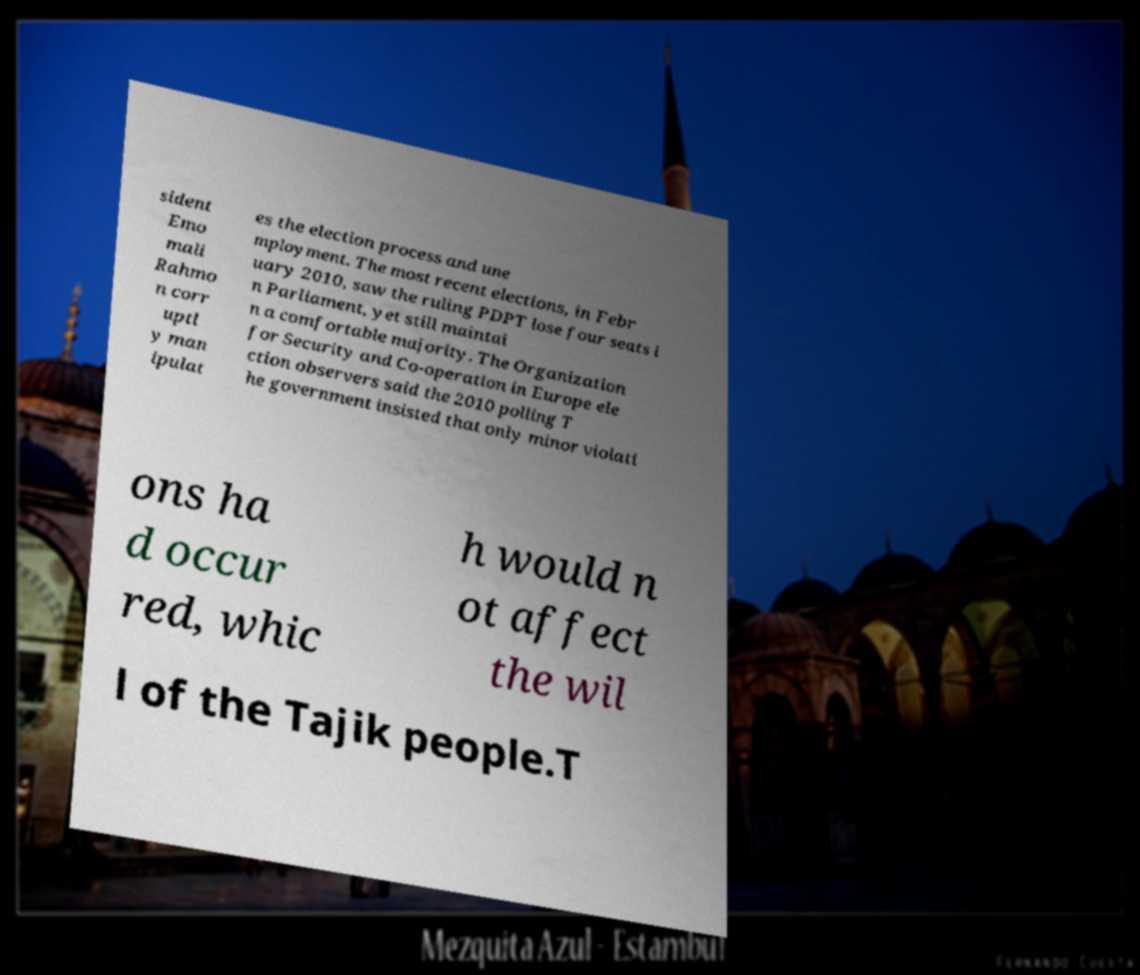There's text embedded in this image that I need extracted. Can you transcribe it verbatim? sident Emo mali Rahmo n corr uptl y man ipulat es the election process and une mployment. The most recent elections, in Febr uary 2010, saw the ruling PDPT lose four seats i n Parliament, yet still maintai n a comfortable majority. The Organization for Security and Co-operation in Europe ele ction observers said the 2010 polling T he government insisted that only minor violati ons ha d occur red, whic h would n ot affect the wil l of the Tajik people.T 